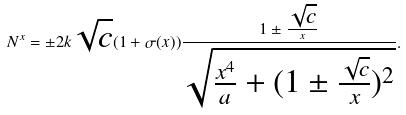<formula> <loc_0><loc_0><loc_500><loc_500>N ^ { x } = \pm 2 k \sqrt { c } ( 1 + \sigma ( x ) ) \frac { 1 \pm \frac { \sqrt { c } } { x } } { \sqrt { \frac { x ^ { 4 } } { a } + ( 1 \pm \frac { \sqrt { c } } { x } ) ^ { 2 } } } .</formula> 